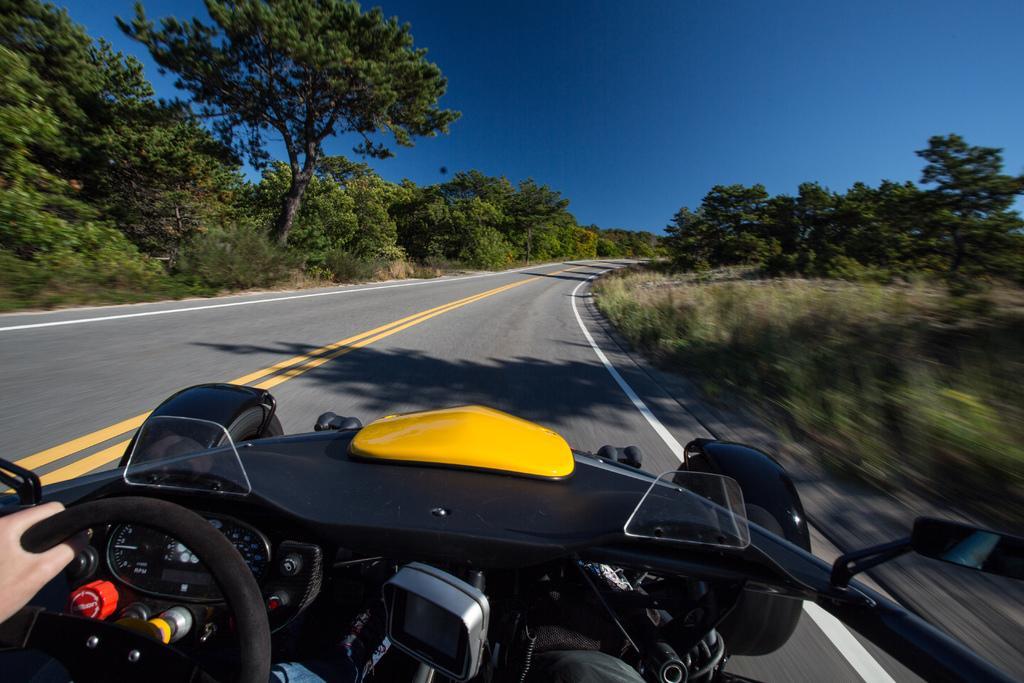How would you summarize this image in a sentence or two? In the background portion of the picture we can see the sky. On either side of the road we can see the trees, plants. At the bottom portion of the picture we can see the hand of a person holding a steering. We can see the partial part of a vehicle. 